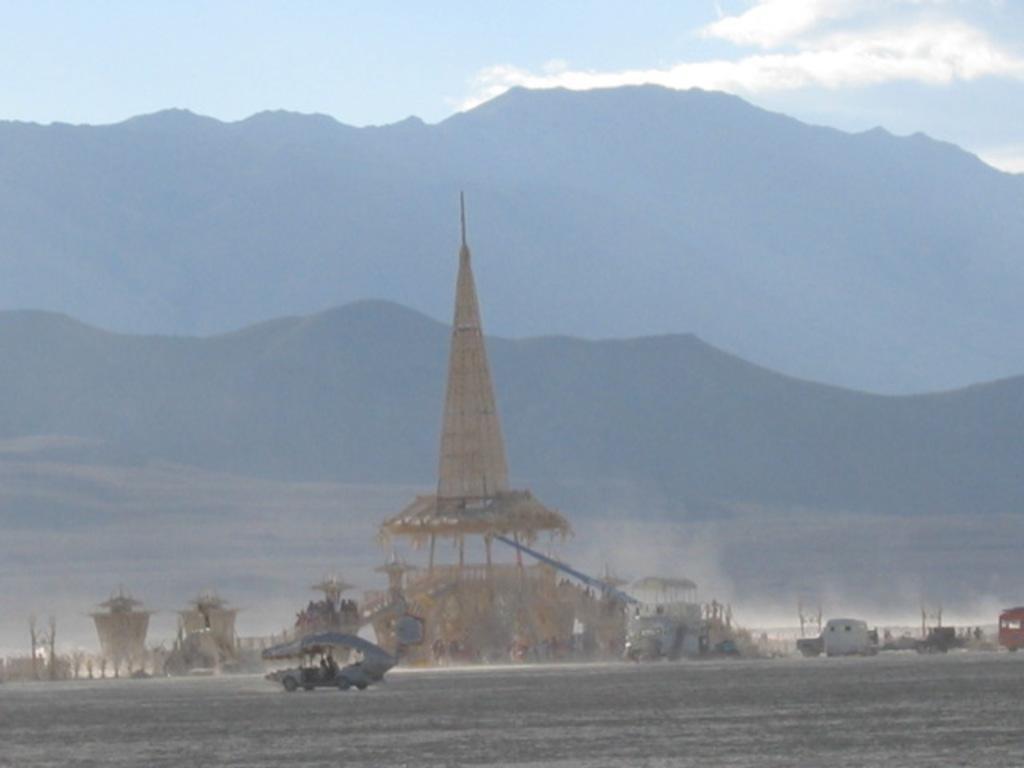Could you give a brief overview of what you see in this image? There are few vehicles and there are few objects beside it and there are mountains in the background. 